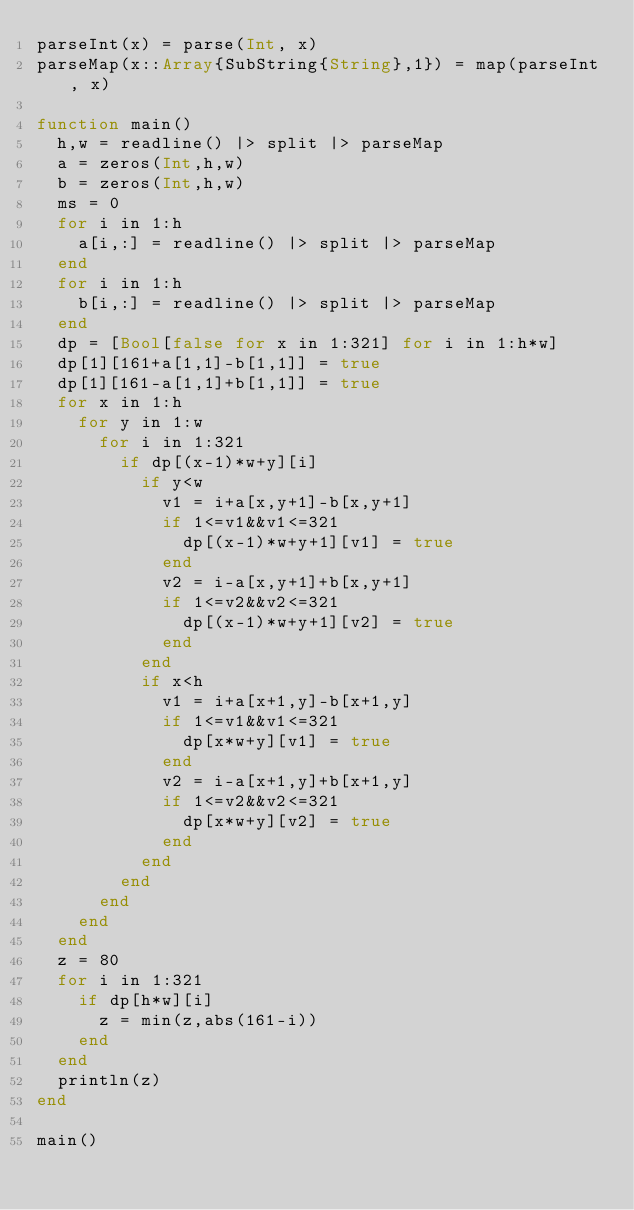<code> <loc_0><loc_0><loc_500><loc_500><_Julia_>parseInt(x) = parse(Int, x)
parseMap(x::Array{SubString{String},1}) = map(parseInt, x)

function main()
	h,w = readline() |> split |> parseMap
	a = zeros(Int,h,w)
	b = zeros(Int,h,w)
	ms = 0
	for i in 1:h
		a[i,:] = readline() |> split |> parseMap
	end
	for i in 1:h
		b[i,:] = readline() |> split |> parseMap
	end
	dp = [Bool[false for x in 1:321] for i in 1:h*w]
	dp[1][161+a[1,1]-b[1,1]] = true
	dp[1][161-a[1,1]+b[1,1]] = true
	for x in 1:h
		for y in 1:w
			for i in 1:321
				if dp[(x-1)*w+y][i]
					if y<w
						v1 = i+a[x,y+1]-b[x,y+1]
						if 1<=v1&&v1<=321
							dp[(x-1)*w+y+1][v1] = true
						end
						v2 = i-a[x,y+1]+b[x,y+1]
						if 1<=v2&&v2<=321
							dp[(x-1)*w+y+1][v2] = true
						end
					end
					if x<h
						v1 = i+a[x+1,y]-b[x+1,y]
						if 1<=v1&&v1<=321
							dp[x*w+y][v1] = true
						end
						v2 = i-a[x+1,y]+b[x+1,y]
						if 1<=v2&&v2<=321
							dp[x*w+y][v2] = true
						end
					end
				end
			end
		end
	end
	z = 80
	for i in 1:321
		if dp[h*w][i]
			z = min(z,abs(161-i))
		end
	end
	println(z)
end

main()

</code> 